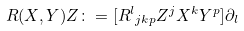<formula> <loc_0><loc_0><loc_500><loc_500>R ( X , Y ) Z \colon = [ { R ^ { l } } _ { j k p } Z ^ { j } X ^ { k } Y ^ { p } ] { \partial } _ { l }</formula> 